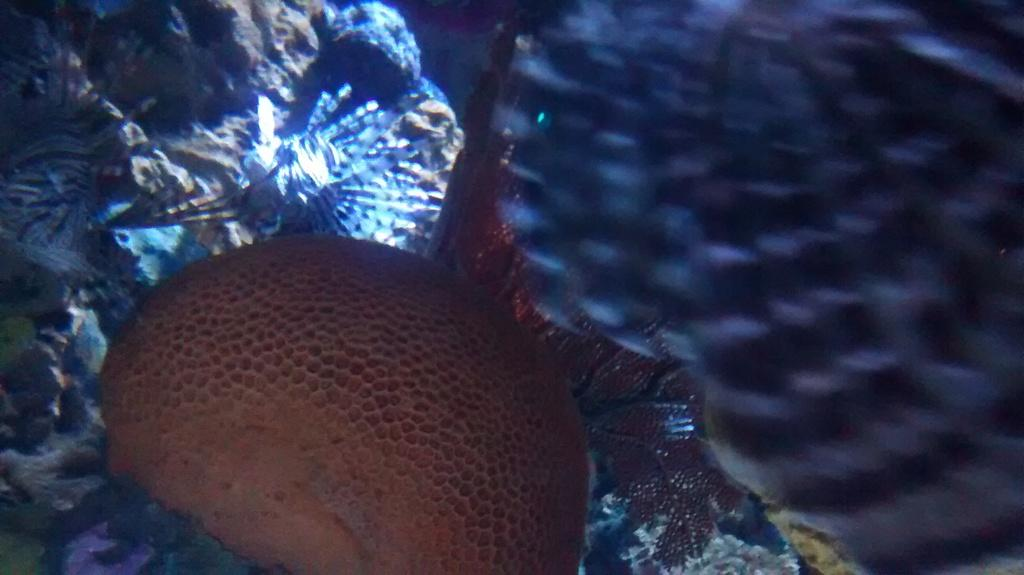What type of animal can be seen in the image? There is a water animal in the image. Where is the water animal located? The water animal is in the water. What type of teeth can be seen on the cave in the image? There is no cave present in the image, and therefore no teeth can be seen on a cave. 